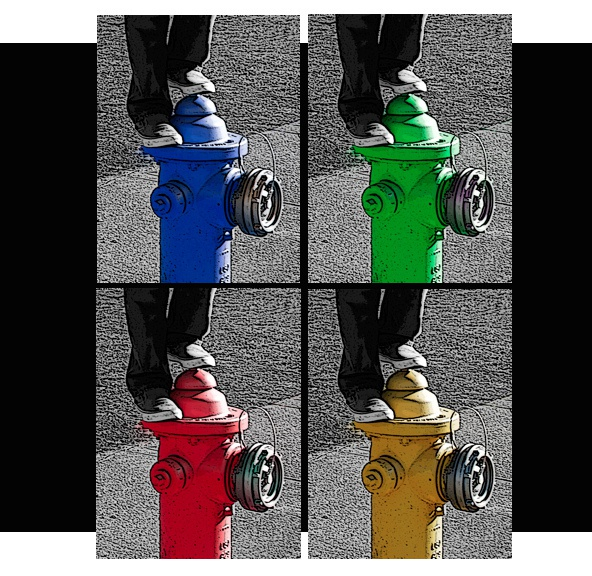Describe the objects in this image and their specific colors. I can see fire hydrant in white, brown, black, maroon, and lightgray tones, fire hydrant in white, green, black, darkgreen, and ivory tones, fire hydrant in white, olive, black, and ivory tones, fire hydrant in white, darkblue, navy, black, and lavender tones, and people in white, black, darkgray, gray, and lightgray tones in this image. 